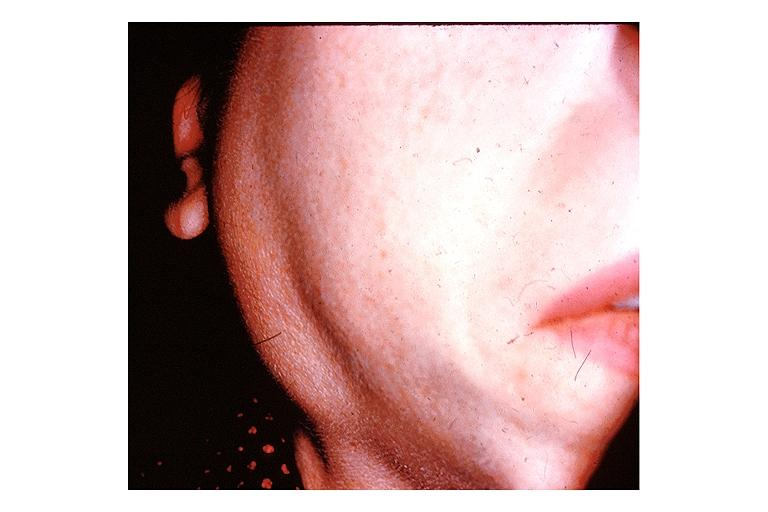where is this?
Answer the question using a single word or phrase. Oral 